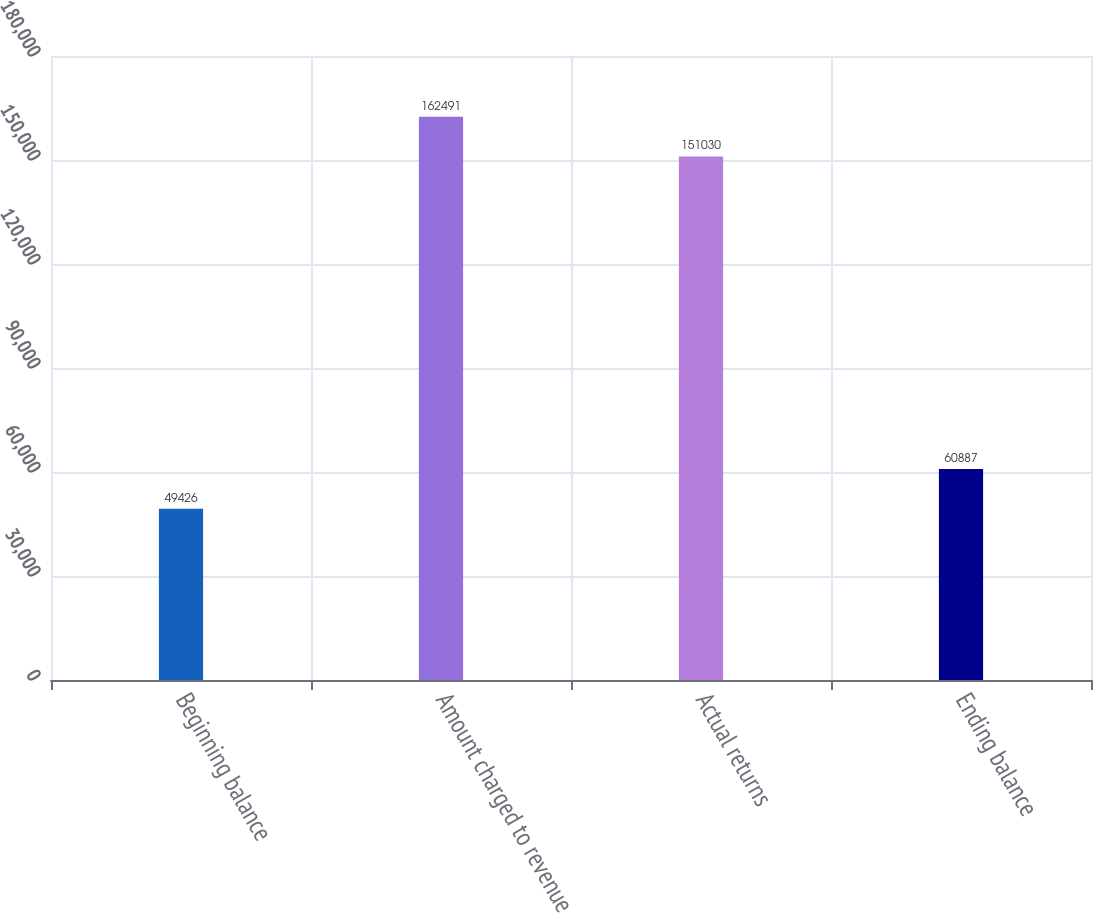Convert chart. <chart><loc_0><loc_0><loc_500><loc_500><bar_chart><fcel>Beginning balance<fcel>Amount charged to revenue<fcel>Actual returns<fcel>Ending balance<nl><fcel>49426<fcel>162491<fcel>151030<fcel>60887<nl></chart> 